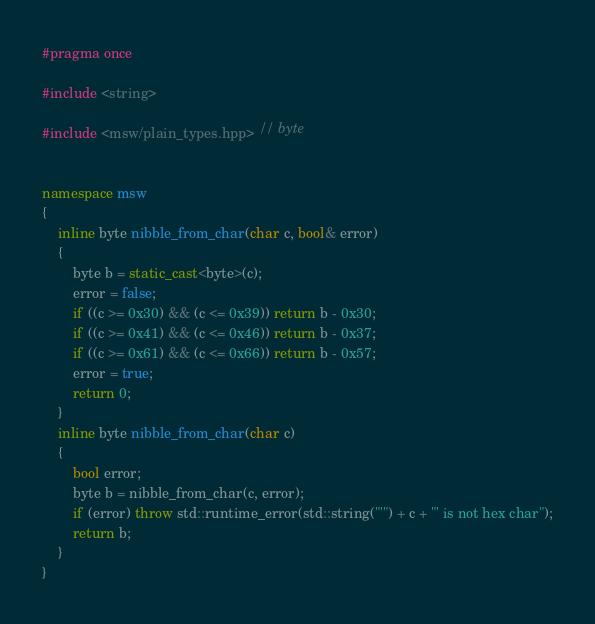<code> <loc_0><loc_0><loc_500><loc_500><_C++_>#pragma once 

#include <string>

#include <msw/plain_types.hpp> // byte


namespace msw
{
    inline byte nibble_from_char(char c, bool& error)
    {
        byte b = static_cast<byte>(c);
        error = false;
        if ((c >= 0x30) && (c <= 0x39)) return b - 0x30;
        if ((c >= 0x41) && (c <= 0x46)) return b - 0x37;
        if ((c >= 0x61) && (c <= 0x66)) return b - 0x57;
        error = true;
        return 0;
    }
    inline byte nibble_from_char(char c)
    {
        bool error;
        byte b = nibble_from_char(c, error);
        if (error) throw std::runtime_error(std::string("'") + c + "' is not hex char");
        return b;
    }
}
</code> 